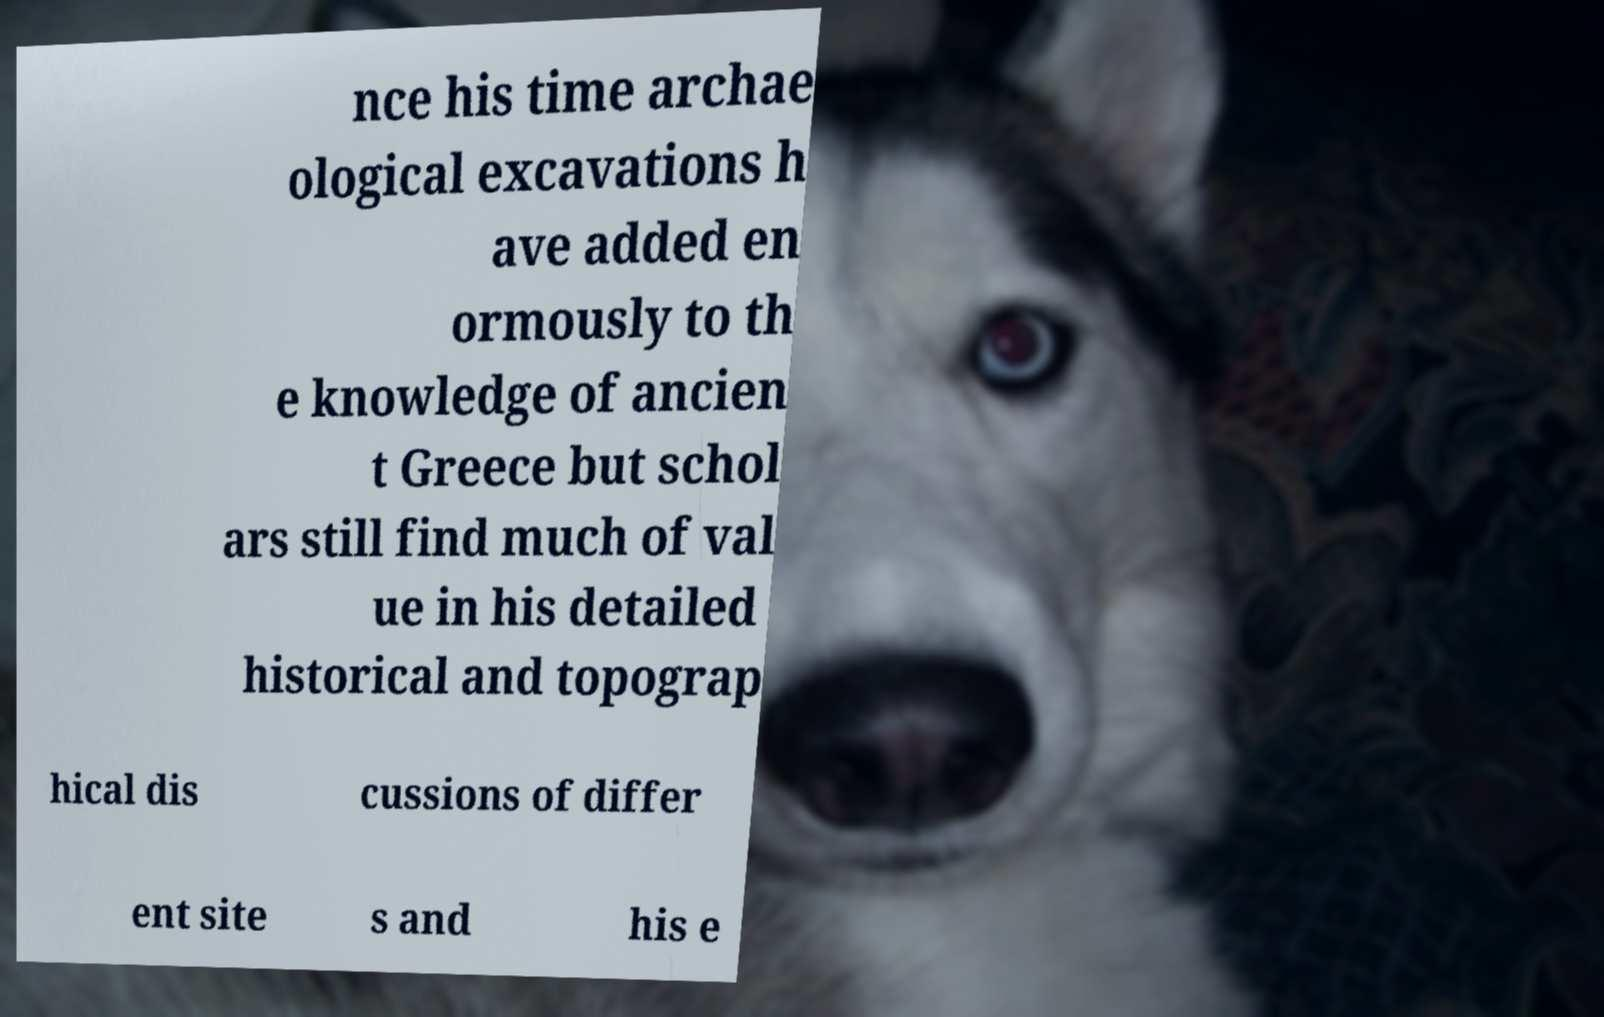Could you assist in decoding the text presented in this image and type it out clearly? nce his time archae ological excavations h ave added en ormously to th e knowledge of ancien t Greece but schol ars still find much of val ue in his detailed historical and topograp hical dis cussions of differ ent site s and his e 